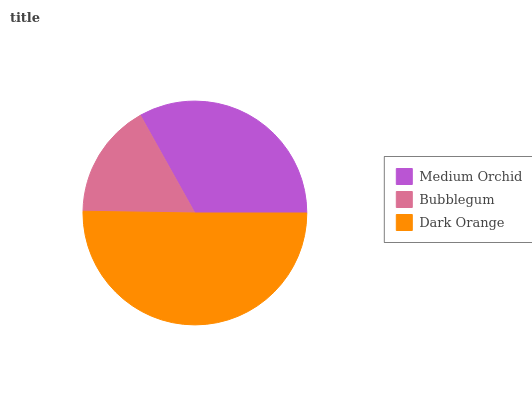Is Bubblegum the minimum?
Answer yes or no. Yes. Is Dark Orange the maximum?
Answer yes or no. Yes. Is Dark Orange the minimum?
Answer yes or no. No. Is Bubblegum the maximum?
Answer yes or no. No. Is Dark Orange greater than Bubblegum?
Answer yes or no. Yes. Is Bubblegum less than Dark Orange?
Answer yes or no. Yes. Is Bubblegum greater than Dark Orange?
Answer yes or no. No. Is Dark Orange less than Bubblegum?
Answer yes or no. No. Is Medium Orchid the high median?
Answer yes or no. Yes. Is Medium Orchid the low median?
Answer yes or no. Yes. Is Dark Orange the high median?
Answer yes or no. No. Is Bubblegum the low median?
Answer yes or no. No. 